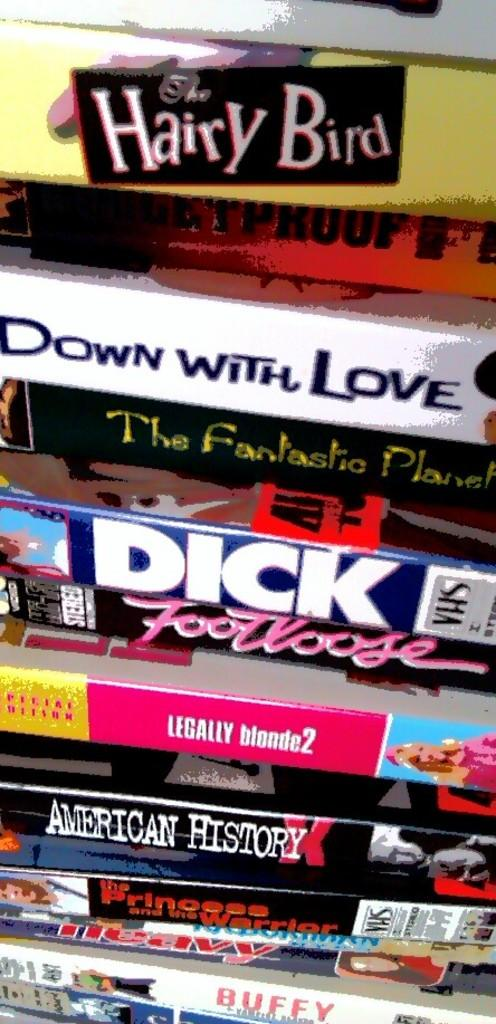Provide a one-sentence caption for the provided image. Many movies are in a large stack, including Hairy Bird, Down with Love, Legally Blonde 2, American History, and Footloose. 